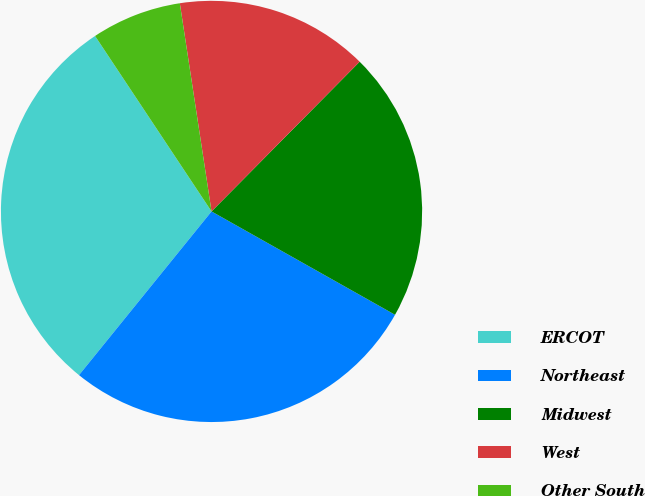Convert chart. <chart><loc_0><loc_0><loc_500><loc_500><pie_chart><fcel>ERCOT<fcel>Northeast<fcel>Midwest<fcel>West<fcel>Other South<nl><fcel>29.84%<fcel>27.67%<fcel>20.75%<fcel>14.82%<fcel>6.92%<nl></chart> 